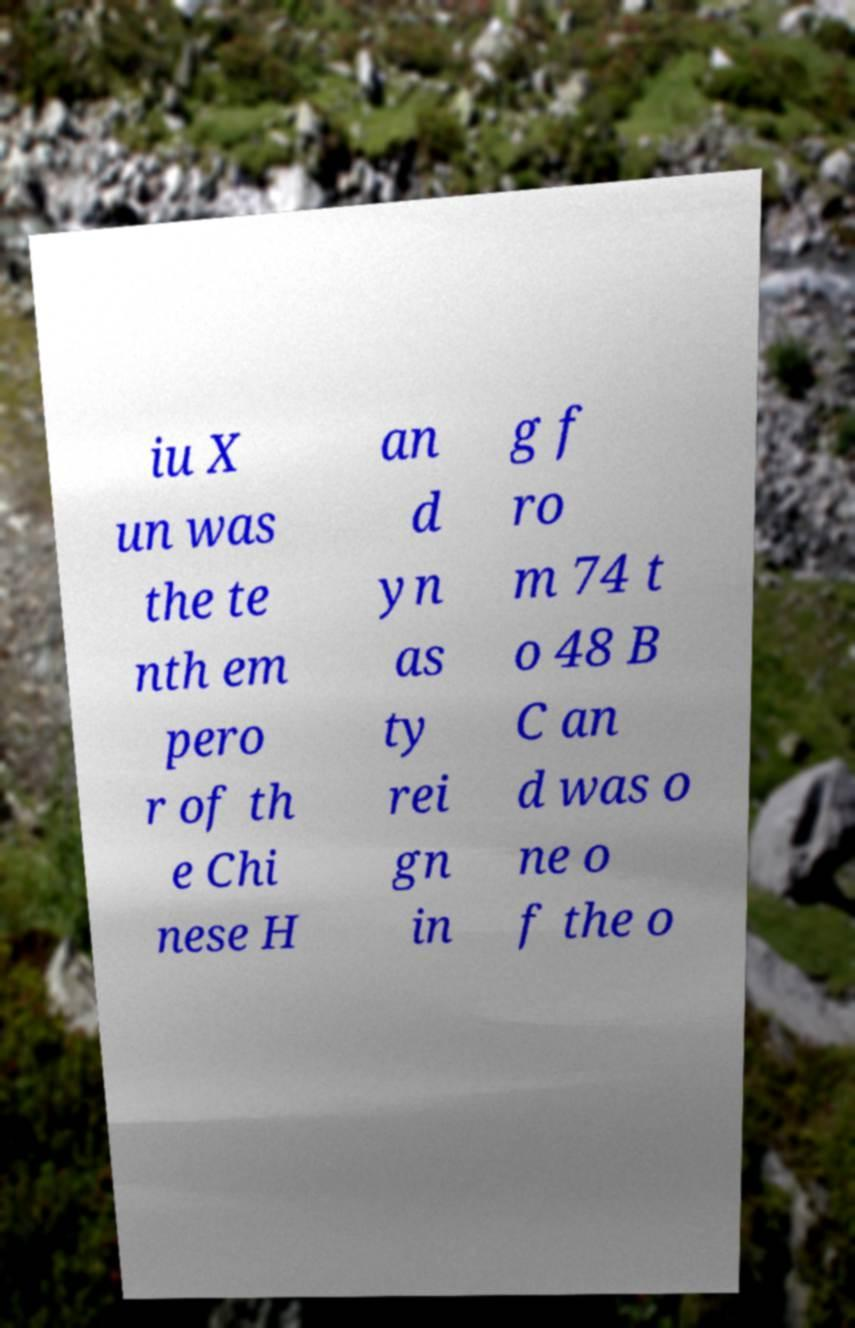What messages or text are displayed in this image? I need them in a readable, typed format. iu X un was the te nth em pero r of th e Chi nese H an d yn as ty rei gn in g f ro m 74 t o 48 B C an d was o ne o f the o 